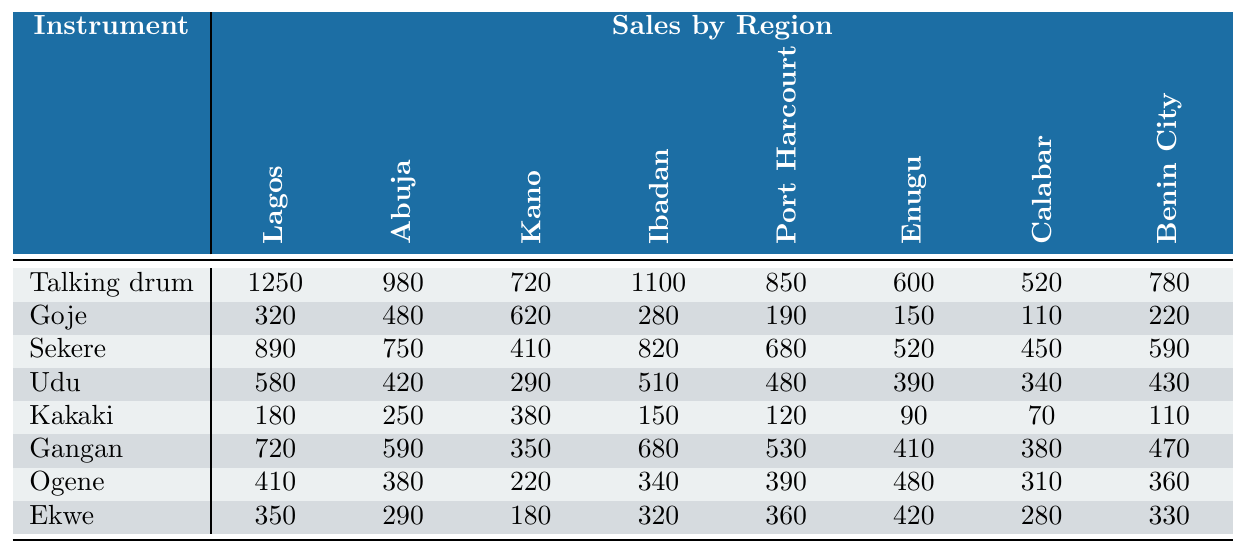What is the highest selling instrument in Lagos? By comparing the sales data for each instrument in Lagos, the Talking drum has the highest sales at 1250 units.
Answer: Talking drum Which region sold the most Goje instruments? Looking at the Goje sales data, Kano sold the most with 620 units.
Answer: Kano What is the total number of Talking drums sold across all regions? To find the total, we add the sales: 1250 + 980 + 720 + 1100 + 850 + 600 + 520 + 780 = 5,800.
Answer: 5800 Which instrument sold the least in Calabar? By examining the Calabar sales, Kakaki sold the least with 70 units.
Answer: Kakaki Did Enugu sell more Ekwe instruments than Udu instruments? In Enugu, Ekwe sold 420 units while Udu sold 390 units, meaning Enugu sold more Ekwe instruments.
Answer: Yes What is the sales difference of Talking drums between Lagos and Ibadan? The sales in Lagos are 1250 and in Ibadan are 1100, so the difference is 1250 - 1100 = 150.
Answer: 150 Which instrument has the highest average price? The average prices show that the Talking drum has the highest price at 85,000 Naira.
Answer: Talking drum What is the total sales of Gangan in all regions combined? Adding the Gangan sales data: 720 + 590 + 350 + 680 + 530 + 410 + 380 + 470 = 3850.
Answer: 3850 How does the sales of Udu in Abuja compare to the sales of Sekere in Ibadan? Udu sold 420 in Abuja, and Sekere sold 820 in Ibadan. Sekere outperformed Udu by 820 - 420 = 400.
Answer: Sekere is higher by 400 Which region has the lowest sales for the Ekwe instrument? By reviewing the Ekwe sales data, Calabar has the lowest sales with 280 units.
Answer: Calabar 